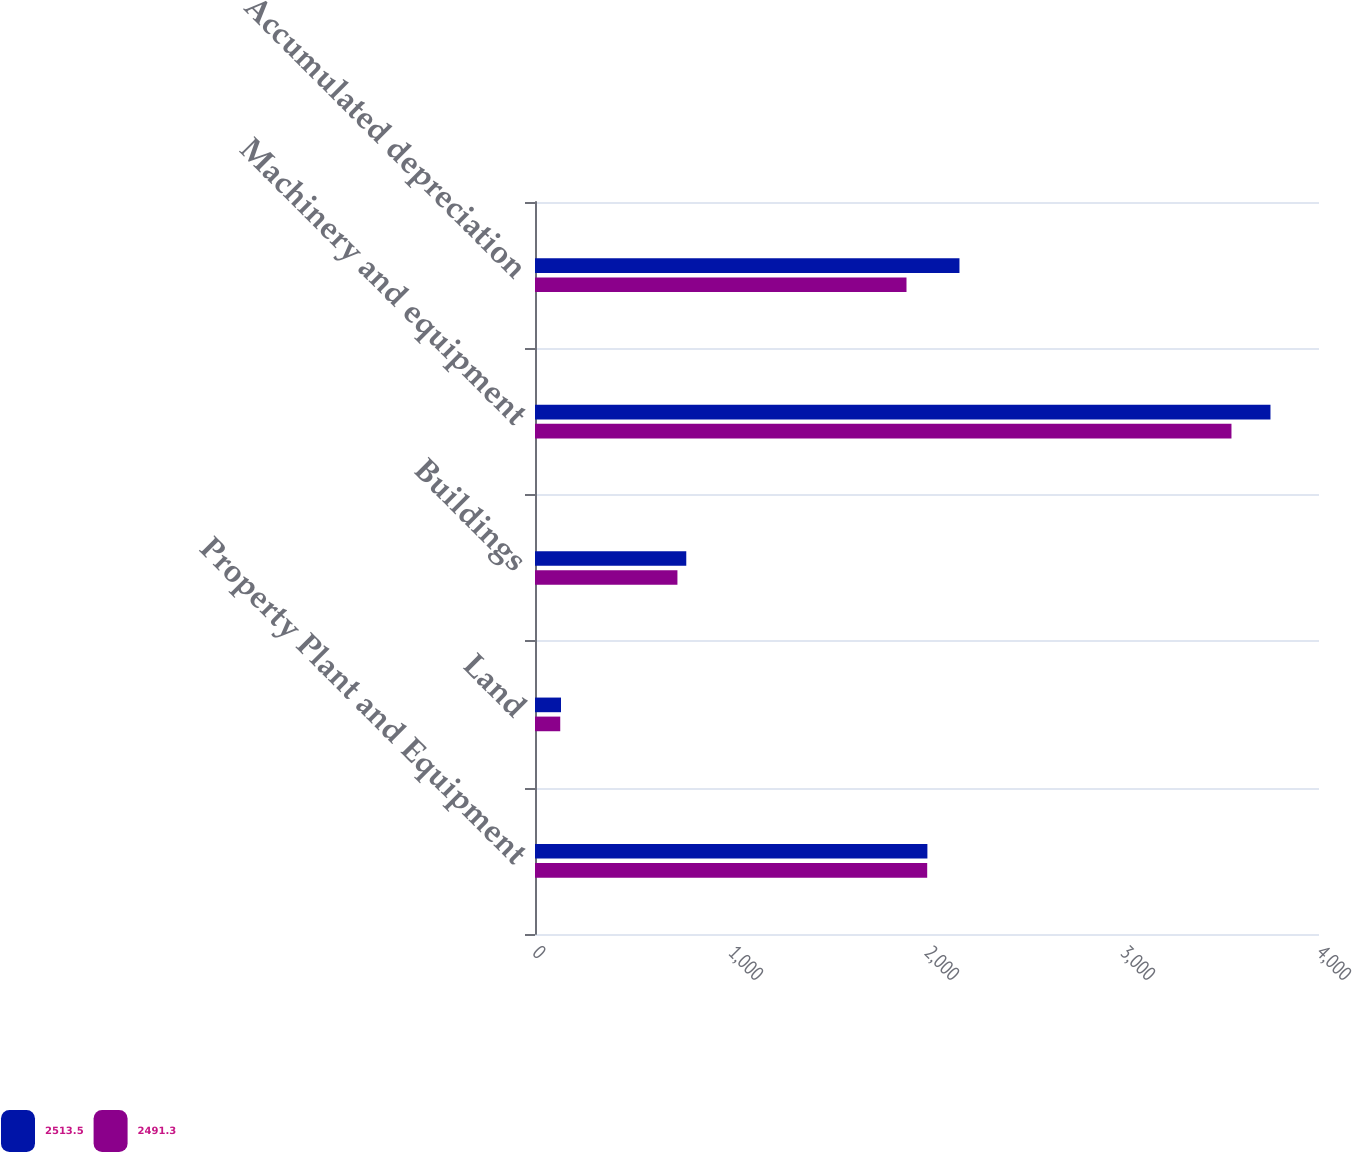<chart> <loc_0><loc_0><loc_500><loc_500><stacked_bar_chart><ecel><fcel>Property Plant and Equipment<fcel>Land<fcel>Buildings<fcel>Machinery and equipment<fcel>Accumulated depreciation<nl><fcel>2513.5<fcel>2002<fcel>132.7<fcel>771.8<fcel>3752.4<fcel>2165.6<nl><fcel>2491.3<fcel>2001<fcel>128.8<fcel>726.7<fcel>3553.4<fcel>1895.4<nl></chart> 